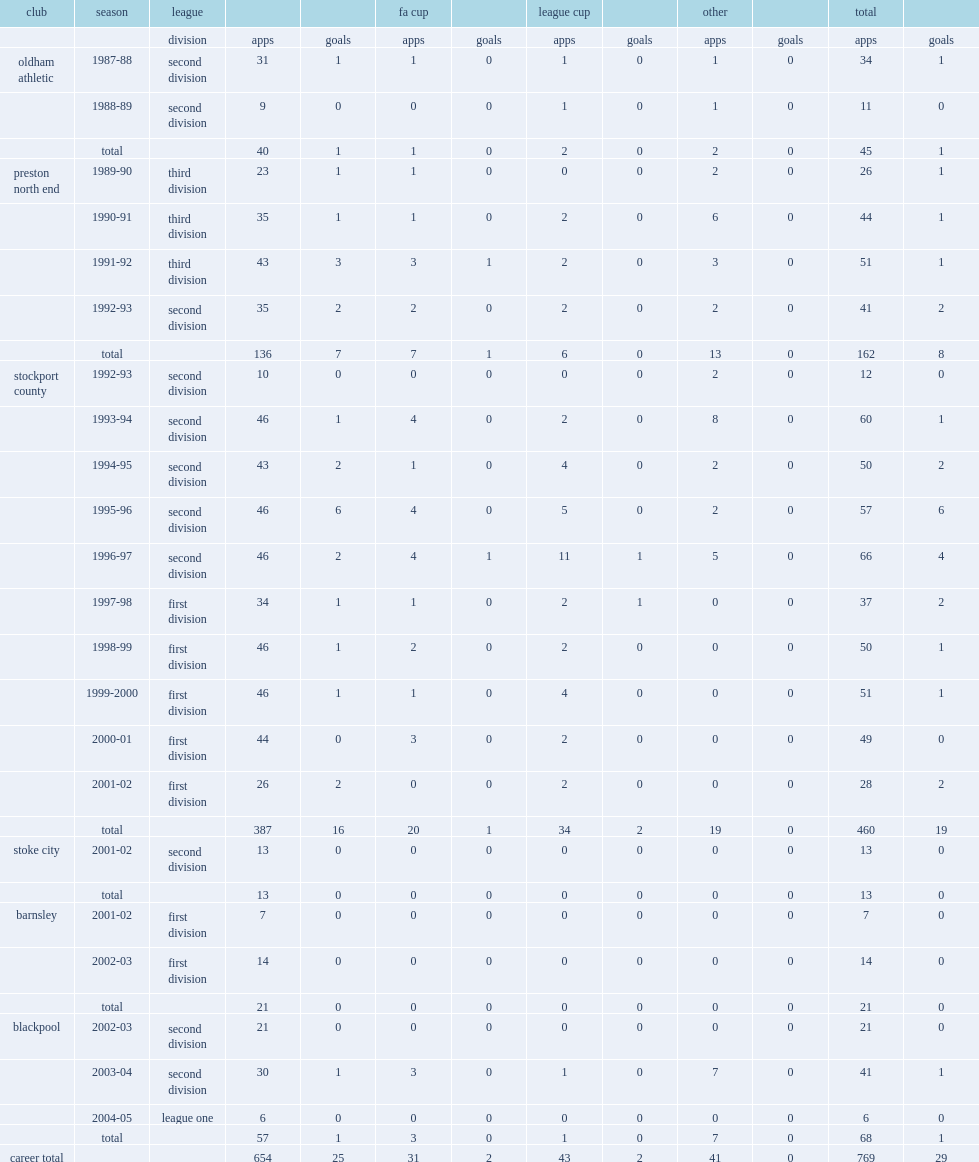How many goals did flynn score in league career? 25.0. 